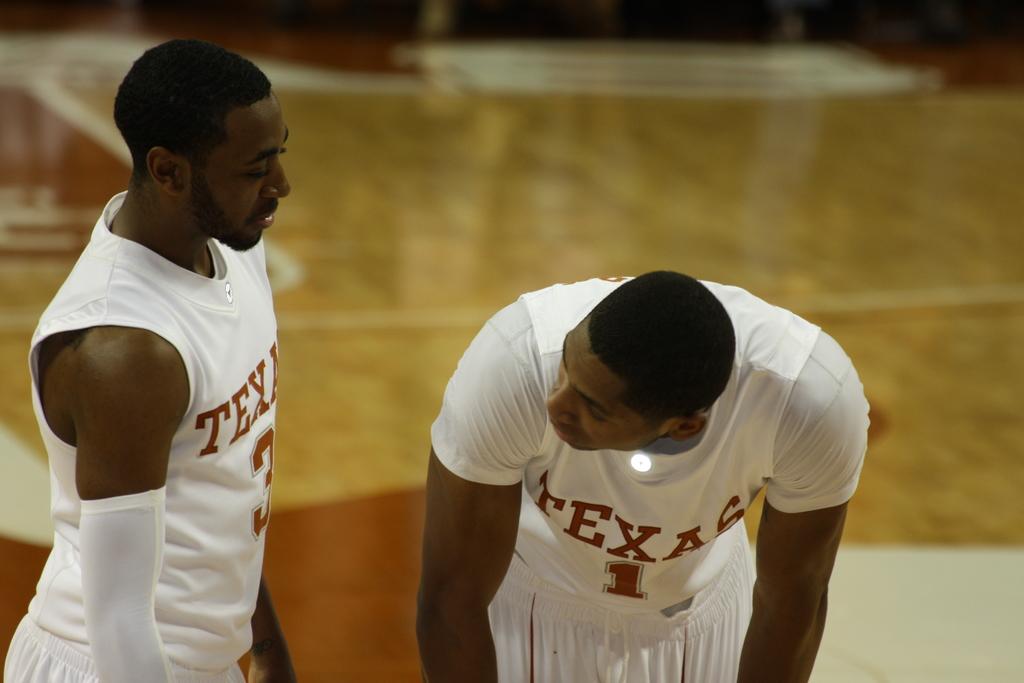What game are they playing?
Your answer should be very brief. Answering does not require reading text in the image. 